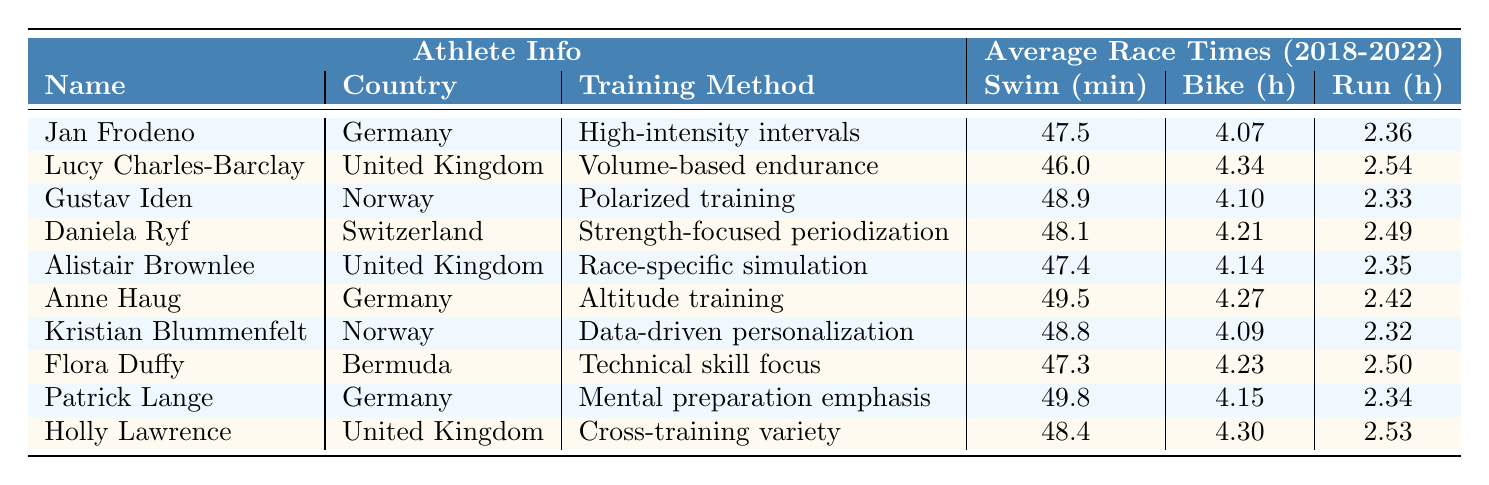What is the average swim time for Jan Frodeno? Jan Frodeno's swim times are 48.2, 47.8, 47.5, 47.1, and 46.9. To find the average, sum these times: 48.2 + 47.8 + 47.5 + 47.1 + 46.9 = 237.5. There are 5 times, so the average is 237.5 / 5 = 47.5.
Answer: 47.5 Which athlete has the fastest average bike time? The average bike times are as follows: Jan Frodeno - 4.07, Lucy Charles-Barclay - 4.34, Gustav Iden - 4.10, Daniela Ryf - 4.21, Alistair Brownlee - 4.14, Anne Haug - 4.27, Kristian Blummenfelt - 4.09, Flora Duffy - 4.23, Patrick Lange - 4.15, and Holly Lawrence - 4.30. The fastest time is 4.07 by Jan Frodeno.
Answer: Jan Frodeno What is the average run time for Lucy Charles-Barclay? Lucy Charles-Barclay's run times are 2.57, 2.55, 2.54, 2.52, and 2.51. Summing these gives 2.57 + 2.55 + 2.54 + 2.52 + 2.51 = 12.69. Dividing by 5 results in an average of 12.69 / 5 = 2.538, which rounds to 2.54.
Answer: 2.54 Which training method is associated with the slowest average swim time? To find the slowest average swim time, calculate the average swim times: Jan Frodeno - 47.5, Lucy Charles-Barclay - 46.0, Gustav Iden - 48.9, Daniela Ryf - 48.1, Alistair Brownlee - 47.4, Anne Haug - 49.5, Kristian Blummenfelt - 48.8, Flora Duffy - 47.3, Patrick Lange - 49.8, Holly Lawrence - 48.4. The slowest average is 49.8 associated with Patrick Lange and his training method is mental preparation emphasis.
Answer: Mental preparation emphasis How much quicker is Alistair Brownlee's average run time compared to Anne Haug's? Alistair Brownlee’s average run time is 2.35, and Anne Haug’s is 2.42. To find the difference: 2.42 - 2.35 = 0.07. Therefore, Alistair Brownlee is 0.07 hours quicker than Anne Haug.
Answer: 0.07 Which athlete has the best average across all three disciplines? Calculate the average for each athlete across swim, bike, and run. Jan Frodeno: (47.5 + 4.07 + 2.36) = 53.93; Lucy Charles-Barclay: (46.0 + 4.34 + 2.54) = 52.88; Gustav Iden: (48.9 + 4.10 + 2.33) = 55.33; Daniela Ryf: (48.1 + 4.21 + 2.49) = 54.80; Alistair Brownlee: (47.4 + 4.14 + 2.35) = 53.89; Anne Haug: (49.5 + 4.27 + 2.42) = 56.19; Kristian Blummenfelt: (48.8 + 4.09 + 2.32) = 55.21; Flora Duffy: (47.3 + 4.23 + 2.50) = 53.03; Patrick Lange: (49.8 + 4.15 + 2.34) = 56.28; Holly Lawrence: (48.4 + 4.30 + 2.53) = 55.23. Lucy Charles-Barclay has the best average at 52.88.
Answer: Lucy Charles-Barclay Is the use of altitude training associated with faster average times in any category? Anne Haug uses altitude training. Her average swim time is 49.5, bike time is 4.27, and run time is 2.42, which are not among the fastest in their respective disciplines. Therefore, altitude training does not show faster average times in this case.
Answer: No How does the average time of athletes using polarized training compare with those using volume-based endurance? The average times for Gustav Iden (polarized training) are: swim 48.9, bike 4.10, and run 2.33, which sum to 55.32. For Lucy Charles-Barclay (volume-based endurance): swim 46.0, bike 4.34, and run 2.54, which sum to 52.88. Thus, polarized training is associated with a slower average time by 2.44 hours.
Answer: Polarized training is slower by 2.44 hours 